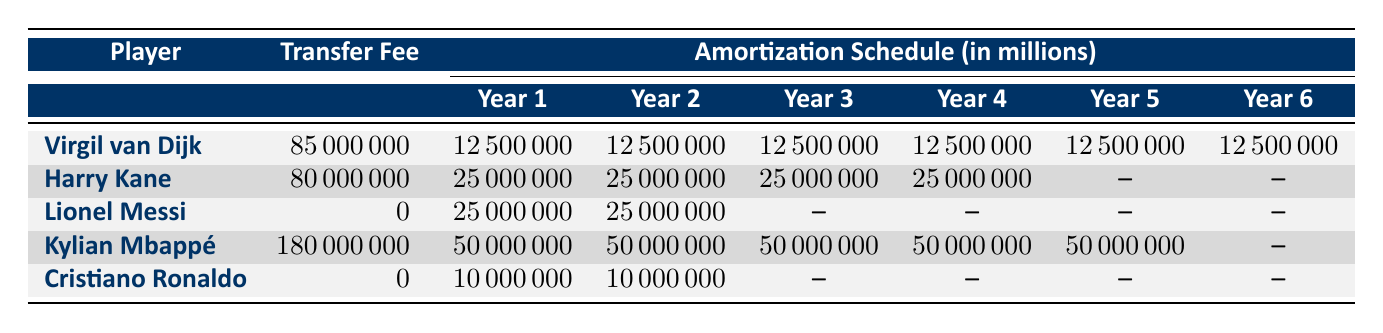What is the transfer fee for Kylian Mbappé? The table shows that the transfer fee for Kylian Mbappé is listed in the second column under the "Transfer Fee" heading. It is 180000000.
Answer: 180000000 How much is the annual amortization for Harry Kane? The annual amortization for Harry Kane can be found in the table under the "Annual Amortization" section, where it indicates that he has an annual amortization of 25000000.
Answer: 25000000 Which player has the highest total contract value? Looking at the "Total Contract Value" column, Kylian Mbappé has the highest total contract value at 250000000, compared to the other players listed.
Answer: Kylian Mbappé What is the average annual amortization of the listed players? To find the average annual amortization, sum the annual amortizations of all players (12500000 + 25000000 + 25000000 + 50000000 + 10000000 = 122500000), then divide by the number of players (5): 122500000 / 5 = 24500000.
Answer: 24500000 Is it true that Cristiano Ronaldo has a higher total contract value than Lionel Messi? By comparing the "Total Contract Value" for both players in the table, Cristiano Ronaldo has 20000000, while Lionel Messi has 50000000. Since 20000000 is less than 50000000, the statement is false.
Answer: No What is the total amount of amortization for Virgil van Dijk over his contract period? The total amount of amortization for Virgil van Dijk can be calculated by summing the values in his amortization schedule: 12500000 + 12500000 + 12500000 + 12500000 + 12500000 + 12500000 = 75000000. This confirms that his total amortization matches his total contract value.
Answer: 75000000 How many players have a contract length of 2 years? By counting the entries in the "Contract Length Years" from the table, we see that both Lionel Messi and Cristiano Ronaldo have a contract length of 2 years. Therefore, there are 2 players.
Answer: 2 What is the difference between the total contract values of Kylian Mbappé and Harry Kane? To find the difference, subtract Harry Kane's total contract value (100000000) from Kylian Mbappé's total contract value (250000000): 250000000 - 100000000 = 150000000.
Answer: 150000000 Is it possible for a player to have an annual amortization of 10000000 and a total contract value of 20000000, based on the table? Yes, Cristiano Ronaldo has an annual amortization of 10000000 and a total contract value of 20000000. This matches the required condition.
Answer: Yes 